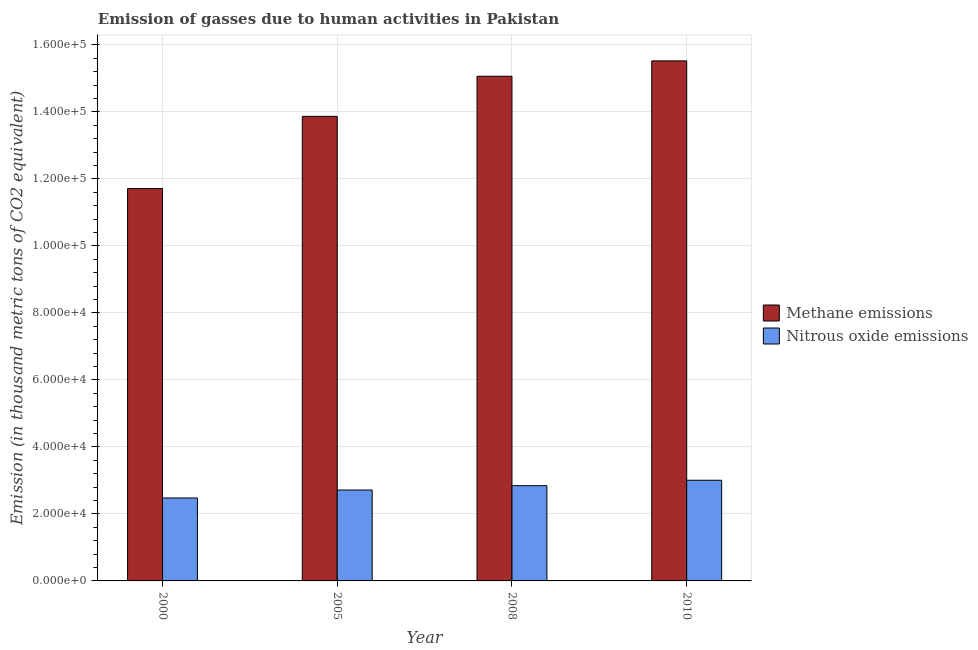How many different coloured bars are there?
Your answer should be very brief. 2. How many groups of bars are there?
Give a very brief answer. 4. Are the number of bars per tick equal to the number of legend labels?
Provide a short and direct response. Yes. Are the number of bars on each tick of the X-axis equal?
Keep it short and to the point. Yes. How many bars are there on the 1st tick from the right?
Your response must be concise. 2. In how many cases, is the number of bars for a given year not equal to the number of legend labels?
Your answer should be very brief. 0. What is the amount of methane emissions in 2005?
Offer a very short reply. 1.39e+05. Across all years, what is the maximum amount of methane emissions?
Give a very brief answer. 1.55e+05. Across all years, what is the minimum amount of methane emissions?
Keep it short and to the point. 1.17e+05. What is the total amount of methane emissions in the graph?
Your answer should be very brief. 5.62e+05. What is the difference between the amount of nitrous oxide emissions in 2000 and that in 2005?
Make the answer very short. -2374.8. What is the difference between the amount of methane emissions in 2008 and the amount of nitrous oxide emissions in 2010?
Your answer should be compact. -4592.5. What is the average amount of methane emissions per year?
Your answer should be very brief. 1.40e+05. In the year 2005, what is the difference between the amount of methane emissions and amount of nitrous oxide emissions?
Provide a succinct answer. 0. What is the ratio of the amount of nitrous oxide emissions in 2000 to that in 2008?
Ensure brevity in your answer.  0.87. Is the amount of nitrous oxide emissions in 2008 less than that in 2010?
Give a very brief answer. Yes. What is the difference between the highest and the second highest amount of methane emissions?
Your answer should be very brief. 4592.5. What is the difference between the highest and the lowest amount of methane emissions?
Keep it short and to the point. 3.81e+04. In how many years, is the amount of nitrous oxide emissions greater than the average amount of nitrous oxide emissions taken over all years?
Keep it short and to the point. 2. What does the 1st bar from the left in 2008 represents?
Provide a succinct answer. Methane emissions. What does the 2nd bar from the right in 2010 represents?
Make the answer very short. Methane emissions. How many bars are there?
Offer a terse response. 8. How many years are there in the graph?
Offer a very short reply. 4. Are the values on the major ticks of Y-axis written in scientific E-notation?
Your answer should be very brief. Yes. Does the graph contain any zero values?
Keep it short and to the point. No. How many legend labels are there?
Keep it short and to the point. 2. How are the legend labels stacked?
Give a very brief answer. Vertical. What is the title of the graph?
Your answer should be compact. Emission of gasses due to human activities in Pakistan. Does "Food" appear as one of the legend labels in the graph?
Keep it short and to the point. No. What is the label or title of the Y-axis?
Provide a short and direct response. Emission (in thousand metric tons of CO2 equivalent). What is the Emission (in thousand metric tons of CO2 equivalent) in Methane emissions in 2000?
Give a very brief answer. 1.17e+05. What is the Emission (in thousand metric tons of CO2 equivalent) of Nitrous oxide emissions in 2000?
Make the answer very short. 2.48e+04. What is the Emission (in thousand metric tons of CO2 equivalent) of Methane emissions in 2005?
Offer a very short reply. 1.39e+05. What is the Emission (in thousand metric tons of CO2 equivalent) in Nitrous oxide emissions in 2005?
Offer a very short reply. 2.71e+04. What is the Emission (in thousand metric tons of CO2 equivalent) of Methane emissions in 2008?
Your answer should be compact. 1.51e+05. What is the Emission (in thousand metric tons of CO2 equivalent) of Nitrous oxide emissions in 2008?
Your answer should be very brief. 2.84e+04. What is the Emission (in thousand metric tons of CO2 equivalent) in Methane emissions in 2010?
Give a very brief answer. 1.55e+05. What is the Emission (in thousand metric tons of CO2 equivalent) in Nitrous oxide emissions in 2010?
Your answer should be compact. 3.01e+04. Across all years, what is the maximum Emission (in thousand metric tons of CO2 equivalent) of Methane emissions?
Your answer should be very brief. 1.55e+05. Across all years, what is the maximum Emission (in thousand metric tons of CO2 equivalent) of Nitrous oxide emissions?
Ensure brevity in your answer.  3.01e+04. Across all years, what is the minimum Emission (in thousand metric tons of CO2 equivalent) of Methane emissions?
Keep it short and to the point. 1.17e+05. Across all years, what is the minimum Emission (in thousand metric tons of CO2 equivalent) of Nitrous oxide emissions?
Offer a very short reply. 2.48e+04. What is the total Emission (in thousand metric tons of CO2 equivalent) of Methane emissions in the graph?
Offer a terse response. 5.62e+05. What is the total Emission (in thousand metric tons of CO2 equivalent) in Nitrous oxide emissions in the graph?
Offer a terse response. 1.10e+05. What is the difference between the Emission (in thousand metric tons of CO2 equivalent) of Methane emissions in 2000 and that in 2005?
Offer a terse response. -2.15e+04. What is the difference between the Emission (in thousand metric tons of CO2 equivalent) of Nitrous oxide emissions in 2000 and that in 2005?
Keep it short and to the point. -2374.8. What is the difference between the Emission (in thousand metric tons of CO2 equivalent) of Methane emissions in 2000 and that in 2008?
Your response must be concise. -3.35e+04. What is the difference between the Emission (in thousand metric tons of CO2 equivalent) in Nitrous oxide emissions in 2000 and that in 2008?
Offer a terse response. -3673.4. What is the difference between the Emission (in thousand metric tons of CO2 equivalent) in Methane emissions in 2000 and that in 2010?
Your answer should be very brief. -3.81e+04. What is the difference between the Emission (in thousand metric tons of CO2 equivalent) of Nitrous oxide emissions in 2000 and that in 2010?
Provide a succinct answer. -5290.5. What is the difference between the Emission (in thousand metric tons of CO2 equivalent) in Methane emissions in 2005 and that in 2008?
Provide a short and direct response. -1.20e+04. What is the difference between the Emission (in thousand metric tons of CO2 equivalent) of Nitrous oxide emissions in 2005 and that in 2008?
Provide a succinct answer. -1298.6. What is the difference between the Emission (in thousand metric tons of CO2 equivalent) of Methane emissions in 2005 and that in 2010?
Provide a succinct answer. -1.66e+04. What is the difference between the Emission (in thousand metric tons of CO2 equivalent) in Nitrous oxide emissions in 2005 and that in 2010?
Provide a short and direct response. -2915.7. What is the difference between the Emission (in thousand metric tons of CO2 equivalent) of Methane emissions in 2008 and that in 2010?
Provide a succinct answer. -4592.5. What is the difference between the Emission (in thousand metric tons of CO2 equivalent) of Nitrous oxide emissions in 2008 and that in 2010?
Give a very brief answer. -1617.1. What is the difference between the Emission (in thousand metric tons of CO2 equivalent) in Methane emissions in 2000 and the Emission (in thousand metric tons of CO2 equivalent) in Nitrous oxide emissions in 2005?
Make the answer very short. 9.00e+04. What is the difference between the Emission (in thousand metric tons of CO2 equivalent) of Methane emissions in 2000 and the Emission (in thousand metric tons of CO2 equivalent) of Nitrous oxide emissions in 2008?
Provide a succinct answer. 8.87e+04. What is the difference between the Emission (in thousand metric tons of CO2 equivalent) in Methane emissions in 2000 and the Emission (in thousand metric tons of CO2 equivalent) in Nitrous oxide emissions in 2010?
Your answer should be compact. 8.71e+04. What is the difference between the Emission (in thousand metric tons of CO2 equivalent) in Methane emissions in 2005 and the Emission (in thousand metric tons of CO2 equivalent) in Nitrous oxide emissions in 2008?
Your answer should be very brief. 1.10e+05. What is the difference between the Emission (in thousand metric tons of CO2 equivalent) of Methane emissions in 2005 and the Emission (in thousand metric tons of CO2 equivalent) of Nitrous oxide emissions in 2010?
Offer a very short reply. 1.09e+05. What is the difference between the Emission (in thousand metric tons of CO2 equivalent) in Methane emissions in 2008 and the Emission (in thousand metric tons of CO2 equivalent) in Nitrous oxide emissions in 2010?
Provide a succinct answer. 1.21e+05. What is the average Emission (in thousand metric tons of CO2 equivalent) in Methane emissions per year?
Provide a succinct answer. 1.40e+05. What is the average Emission (in thousand metric tons of CO2 equivalent) of Nitrous oxide emissions per year?
Provide a short and direct response. 2.76e+04. In the year 2000, what is the difference between the Emission (in thousand metric tons of CO2 equivalent) in Methane emissions and Emission (in thousand metric tons of CO2 equivalent) in Nitrous oxide emissions?
Provide a succinct answer. 9.24e+04. In the year 2005, what is the difference between the Emission (in thousand metric tons of CO2 equivalent) of Methane emissions and Emission (in thousand metric tons of CO2 equivalent) of Nitrous oxide emissions?
Offer a very short reply. 1.12e+05. In the year 2008, what is the difference between the Emission (in thousand metric tons of CO2 equivalent) in Methane emissions and Emission (in thousand metric tons of CO2 equivalent) in Nitrous oxide emissions?
Provide a short and direct response. 1.22e+05. In the year 2010, what is the difference between the Emission (in thousand metric tons of CO2 equivalent) in Methane emissions and Emission (in thousand metric tons of CO2 equivalent) in Nitrous oxide emissions?
Provide a succinct answer. 1.25e+05. What is the ratio of the Emission (in thousand metric tons of CO2 equivalent) in Methane emissions in 2000 to that in 2005?
Offer a very short reply. 0.84. What is the ratio of the Emission (in thousand metric tons of CO2 equivalent) in Nitrous oxide emissions in 2000 to that in 2005?
Offer a terse response. 0.91. What is the ratio of the Emission (in thousand metric tons of CO2 equivalent) of Methane emissions in 2000 to that in 2008?
Provide a succinct answer. 0.78. What is the ratio of the Emission (in thousand metric tons of CO2 equivalent) of Nitrous oxide emissions in 2000 to that in 2008?
Your answer should be very brief. 0.87. What is the ratio of the Emission (in thousand metric tons of CO2 equivalent) of Methane emissions in 2000 to that in 2010?
Your answer should be very brief. 0.75. What is the ratio of the Emission (in thousand metric tons of CO2 equivalent) in Nitrous oxide emissions in 2000 to that in 2010?
Offer a very short reply. 0.82. What is the ratio of the Emission (in thousand metric tons of CO2 equivalent) of Methane emissions in 2005 to that in 2008?
Offer a terse response. 0.92. What is the ratio of the Emission (in thousand metric tons of CO2 equivalent) of Nitrous oxide emissions in 2005 to that in 2008?
Your answer should be very brief. 0.95. What is the ratio of the Emission (in thousand metric tons of CO2 equivalent) in Methane emissions in 2005 to that in 2010?
Offer a very short reply. 0.89. What is the ratio of the Emission (in thousand metric tons of CO2 equivalent) in Nitrous oxide emissions in 2005 to that in 2010?
Offer a very short reply. 0.9. What is the ratio of the Emission (in thousand metric tons of CO2 equivalent) in Methane emissions in 2008 to that in 2010?
Your answer should be compact. 0.97. What is the ratio of the Emission (in thousand metric tons of CO2 equivalent) in Nitrous oxide emissions in 2008 to that in 2010?
Ensure brevity in your answer.  0.95. What is the difference between the highest and the second highest Emission (in thousand metric tons of CO2 equivalent) of Methane emissions?
Make the answer very short. 4592.5. What is the difference between the highest and the second highest Emission (in thousand metric tons of CO2 equivalent) in Nitrous oxide emissions?
Keep it short and to the point. 1617.1. What is the difference between the highest and the lowest Emission (in thousand metric tons of CO2 equivalent) of Methane emissions?
Provide a succinct answer. 3.81e+04. What is the difference between the highest and the lowest Emission (in thousand metric tons of CO2 equivalent) in Nitrous oxide emissions?
Provide a short and direct response. 5290.5. 